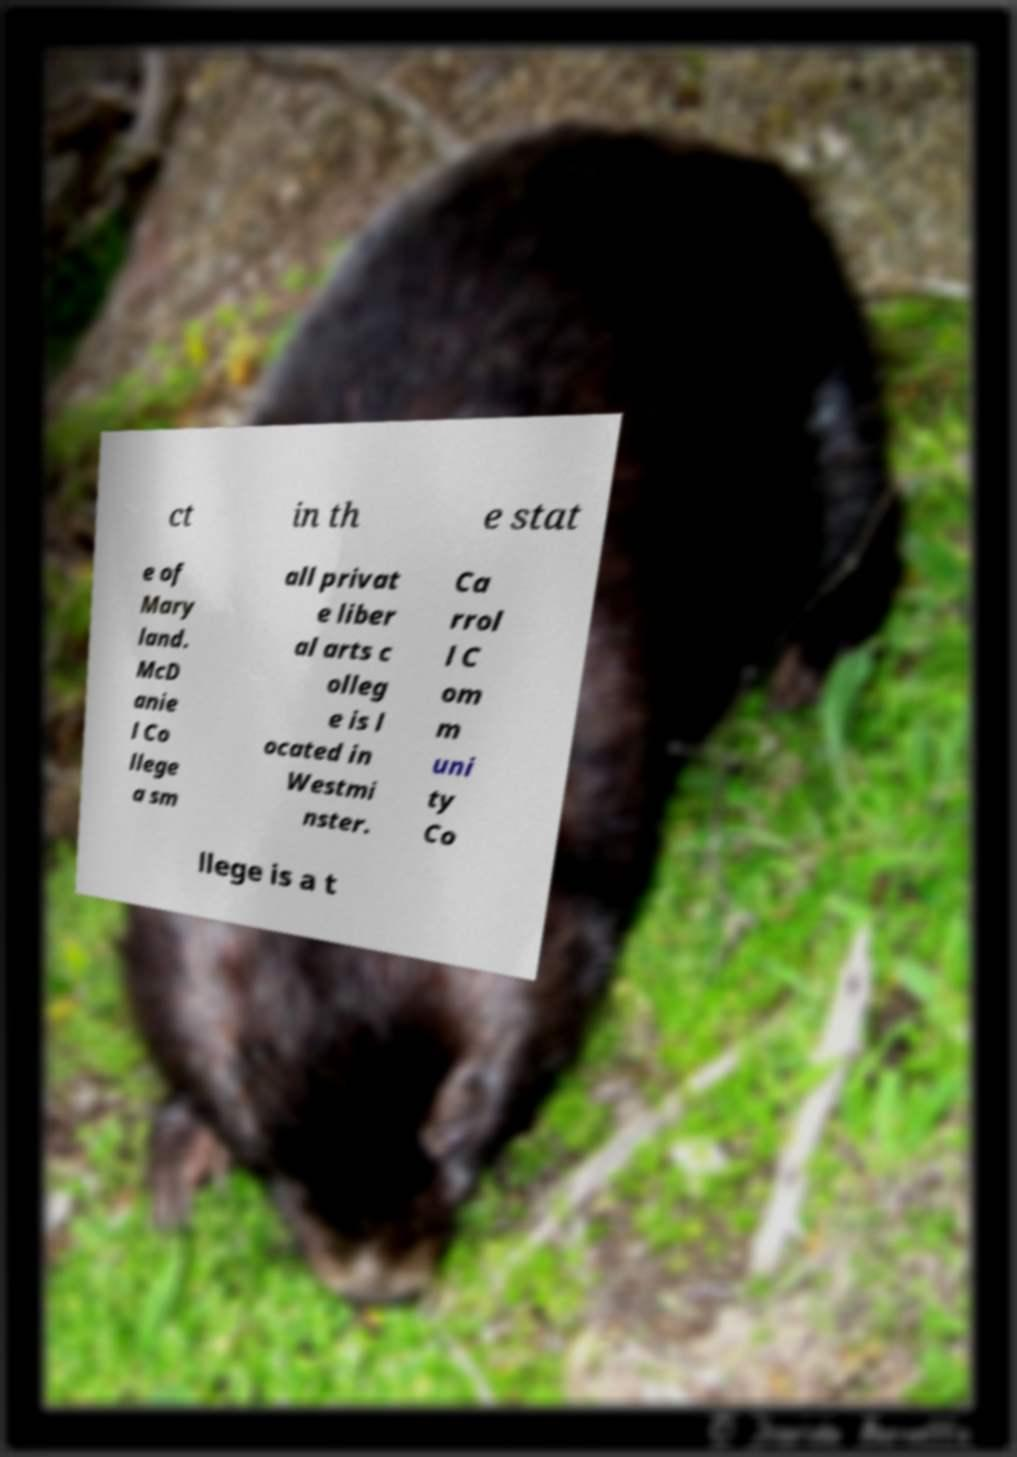Could you extract and type out the text from this image? ct in th e stat e of Mary land. McD anie l Co llege a sm all privat e liber al arts c olleg e is l ocated in Westmi nster. Ca rrol l C om m uni ty Co llege is a t 